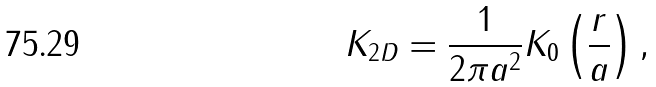Convert formula to latex. <formula><loc_0><loc_0><loc_500><loc_500>K _ { 2 D } = \frac { 1 } { 2 \pi a ^ { 2 } } K _ { 0 } \left ( \frac { r } { a } \right ) ,</formula> 